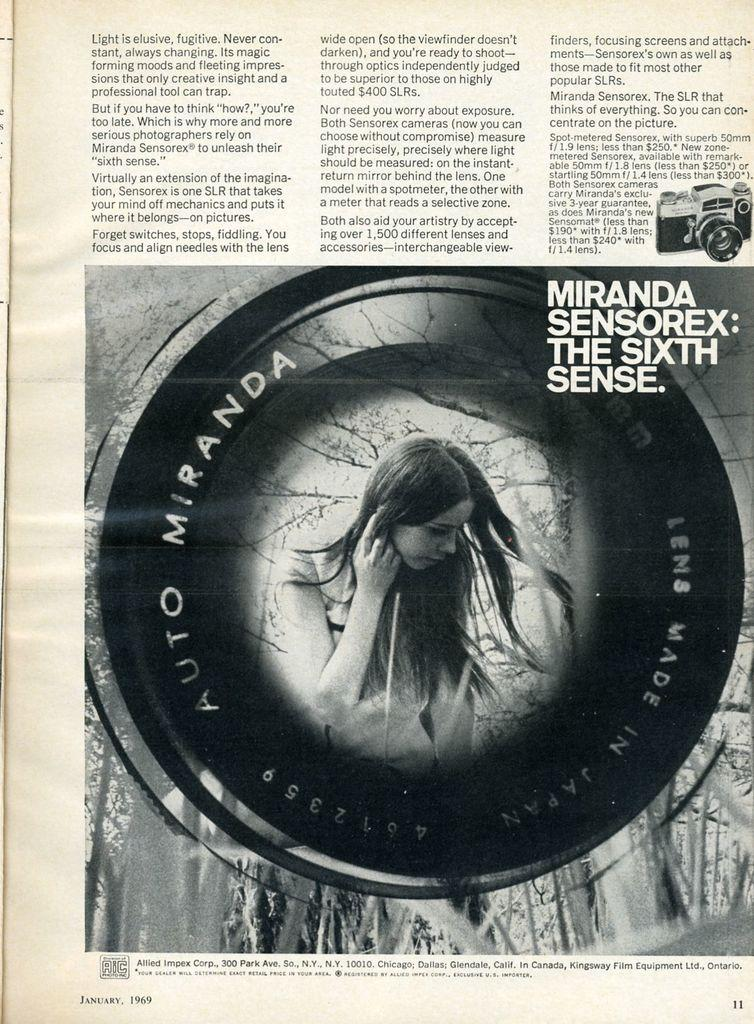What is depicted on the paper in the image? There is a paper with an image and text in the image. Who is present in the image? There is a woman in the image. What can be seen at the top of the image? There is text at the top of the image. What is located on the right side of the image? There is a camera image on the right side of the image. How many doors are visible in the image? There are no doors present in the image. What type of fowl can be seen in the image? There is no fowl present in the image. 